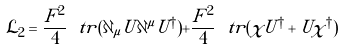<formula> <loc_0><loc_0><loc_500><loc_500>\mathcal { L } _ { 2 } = \frac { F ^ { 2 } } { 4 } \ t r ( \partial _ { \mu } U \partial ^ { \mu } U ^ { \dagger } ) + \frac { F ^ { 2 } } { 4 } \ t r ( \chi U ^ { \dagger } + U \chi ^ { \dagger } )</formula> 